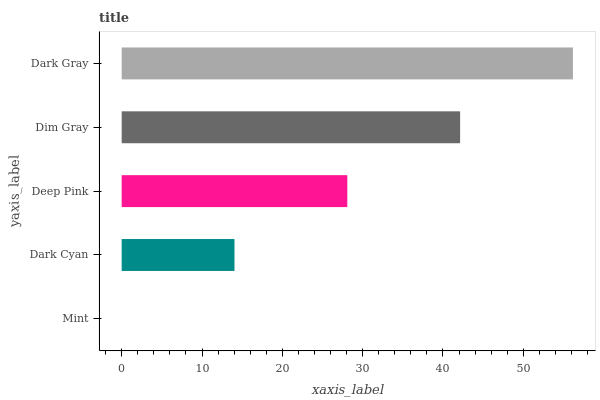Is Mint the minimum?
Answer yes or no. Yes. Is Dark Gray the maximum?
Answer yes or no. Yes. Is Dark Cyan the minimum?
Answer yes or no. No. Is Dark Cyan the maximum?
Answer yes or no. No. Is Dark Cyan greater than Mint?
Answer yes or no. Yes. Is Mint less than Dark Cyan?
Answer yes or no. Yes. Is Mint greater than Dark Cyan?
Answer yes or no. No. Is Dark Cyan less than Mint?
Answer yes or no. No. Is Deep Pink the high median?
Answer yes or no. Yes. Is Deep Pink the low median?
Answer yes or no. Yes. Is Mint the high median?
Answer yes or no. No. Is Mint the low median?
Answer yes or no. No. 